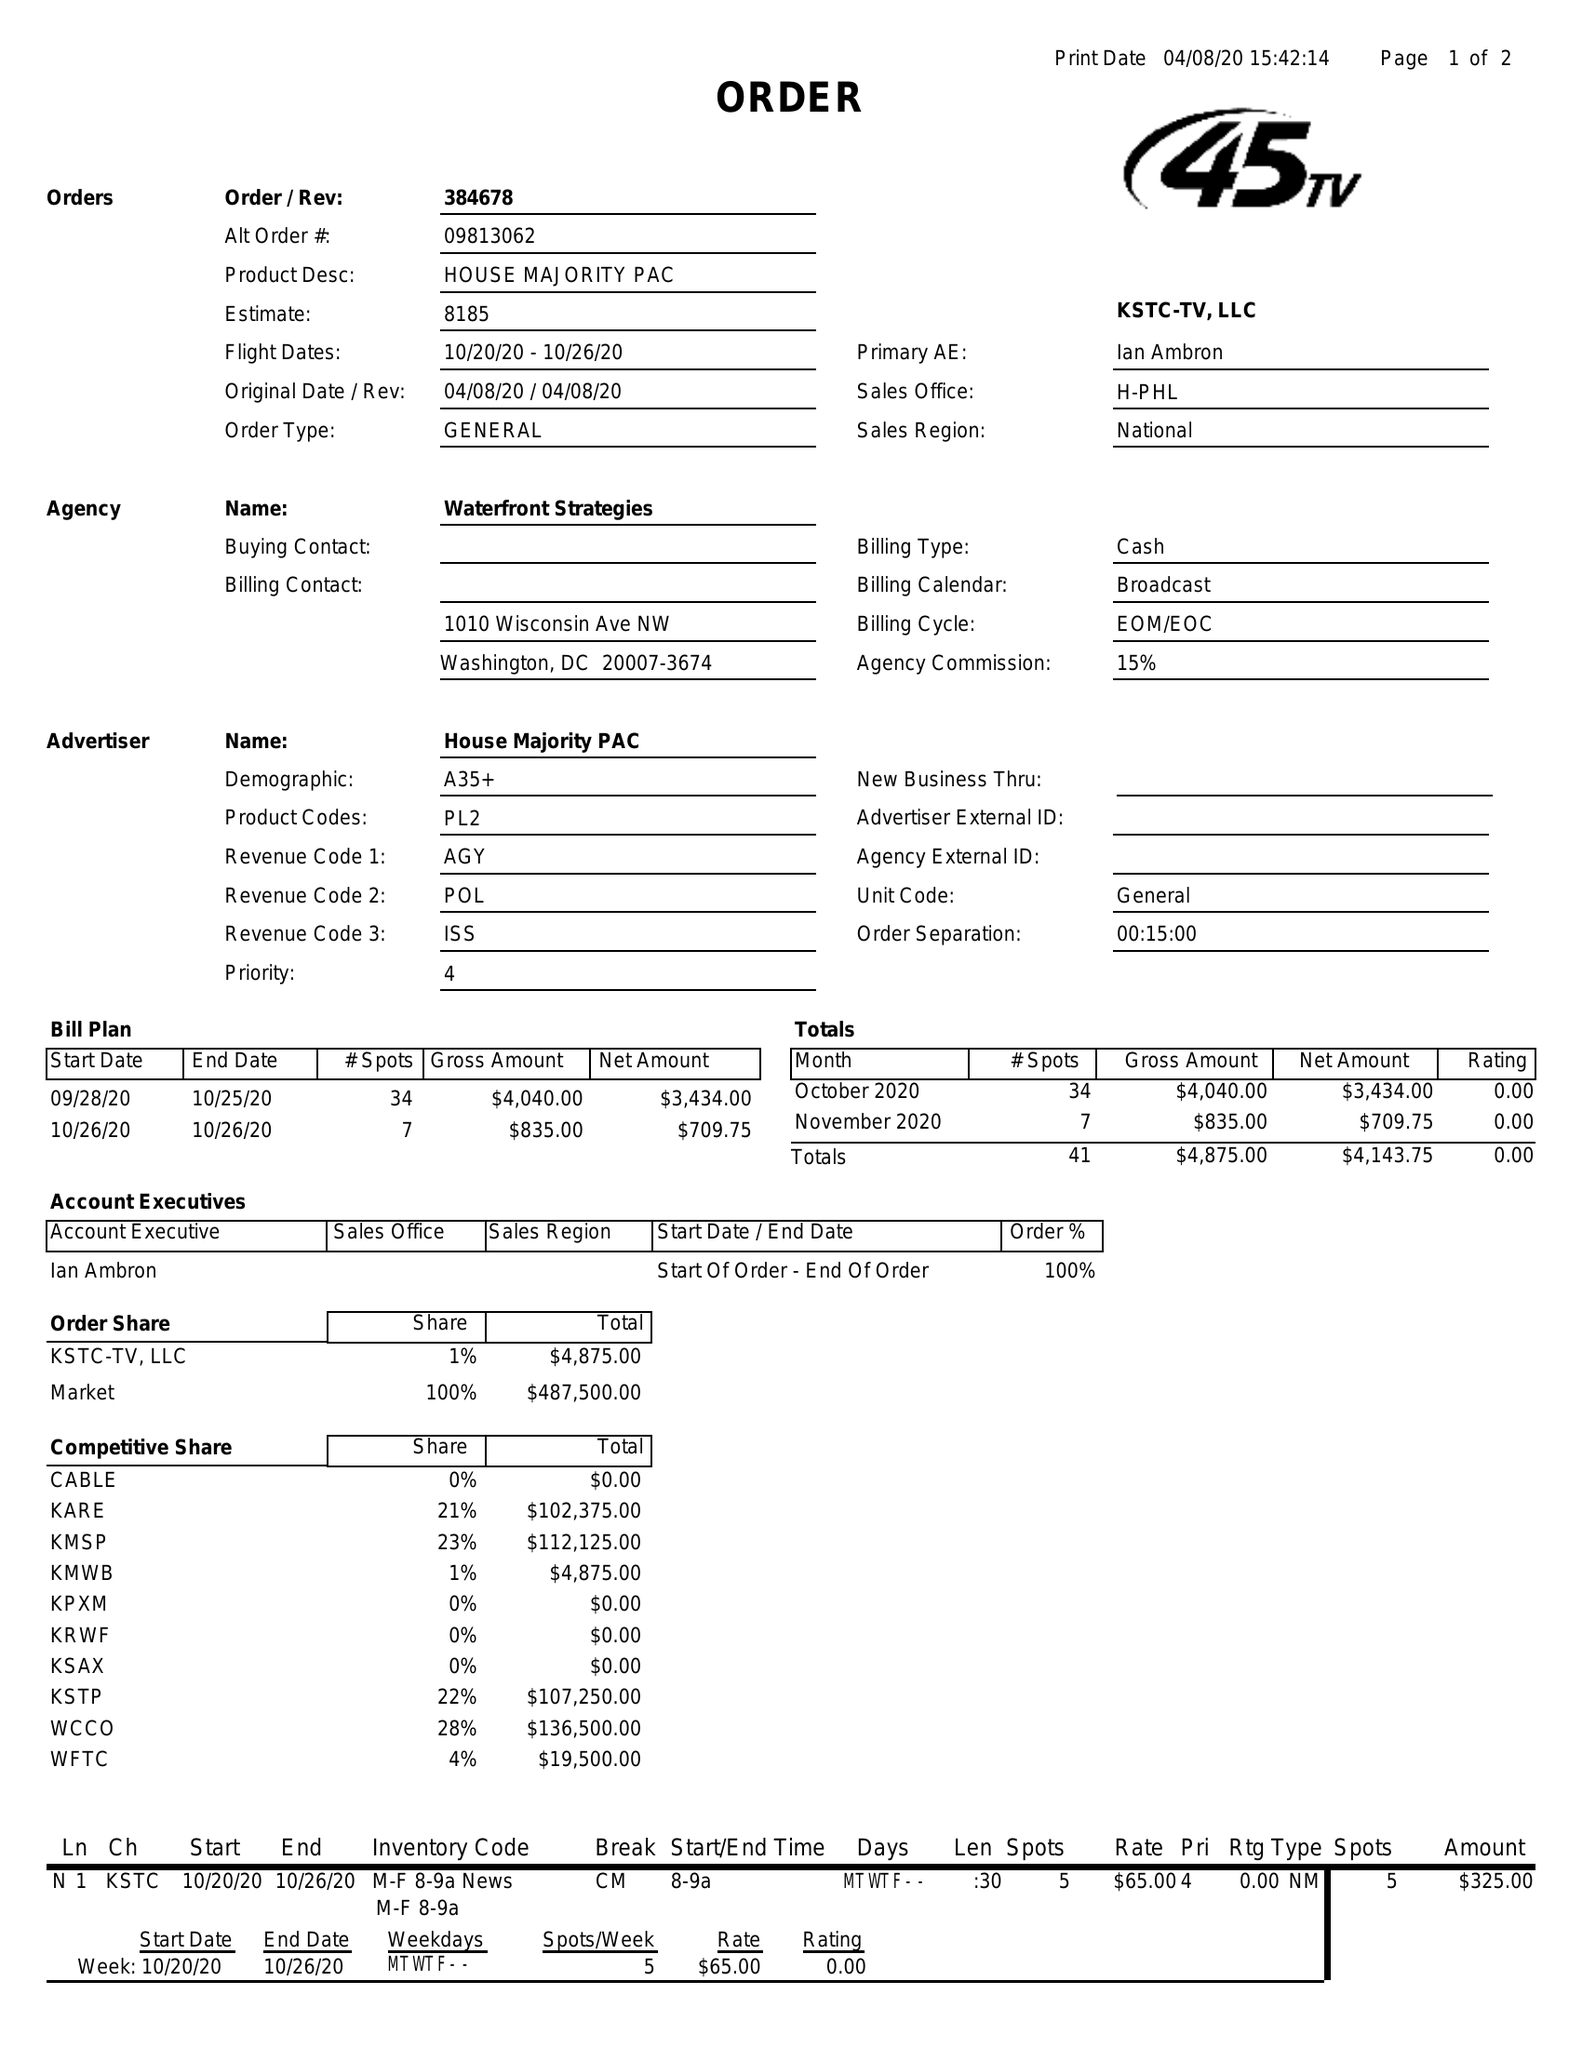What is the value for the contract_num?
Answer the question using a single word or phrase. 384678 